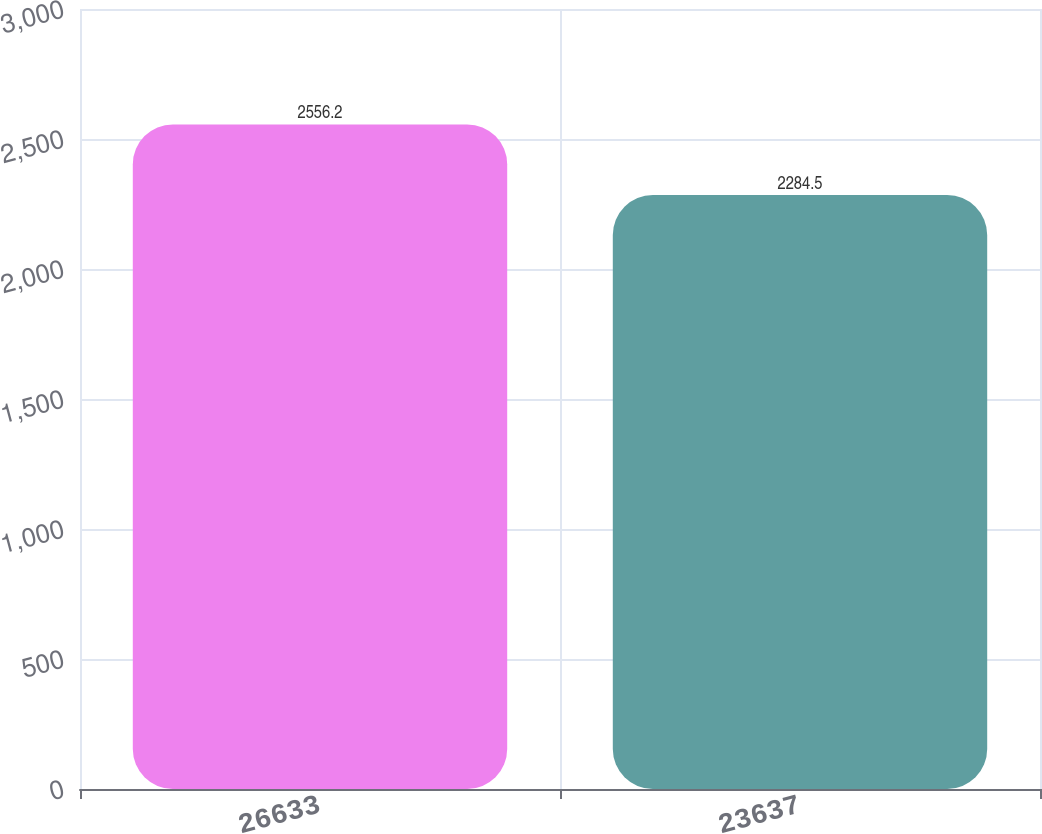Convert chart. <chart><loc_0><loc_0><loc_500><loc_500><bar_chart><fcel>26633<fcel>23637<nl><fcel>2556.2<fcel>2284.5<nl></chart> 